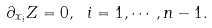Convert formula to latex. <formula><loc_0><loc_0><loc_500><loc_500>\partial _ { x _ { i } } Z = 0 , \ i = 1 , \cdots , n - 1 .</formula> 